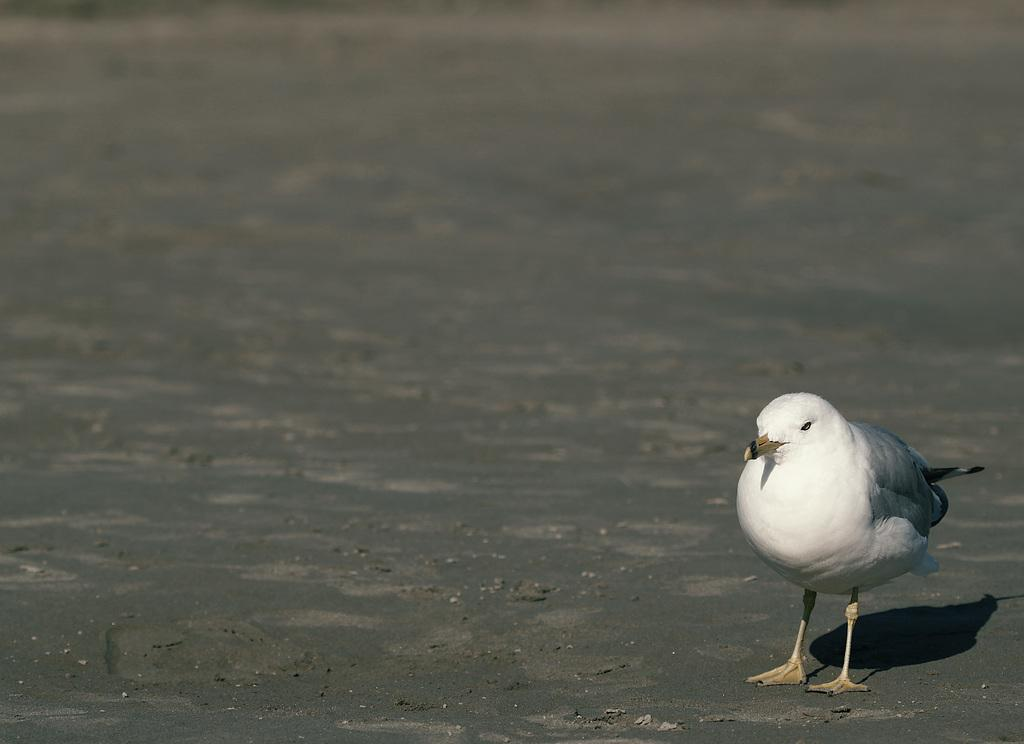What type of animal can be seen on the right side of the image? There is a bird on the right side of the image. What is the bird standing on? The bird is standing on wet sand. What color is the bird in the image? The bird is white in color. What type of sign can be seen in the image? There is no sign present in the image; it features a bird standing on wet sand. How many bananas are visible in the image? There are no bananas present in the image. 